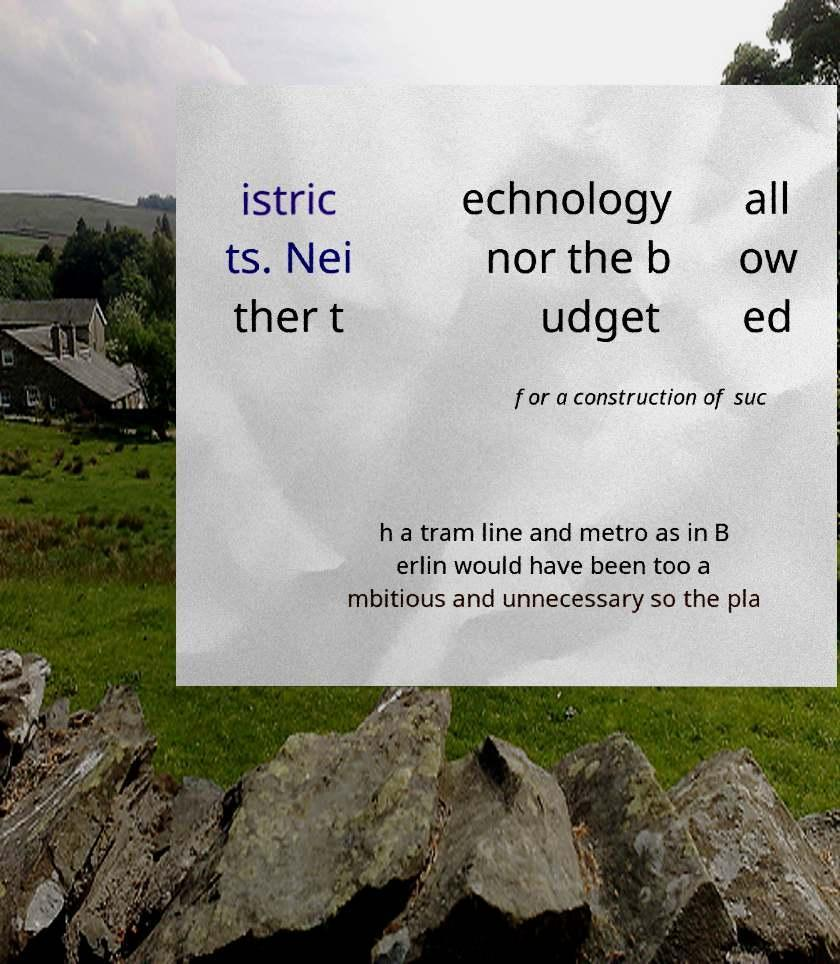I need the written content from this picture converted into text. Can you do that? istric ts. Nei ther t echnology nor the b udget all ow ed for a construction of suc h a tram line and metro as in B erlin would have been too a mbitious and unnecessary so the pla 